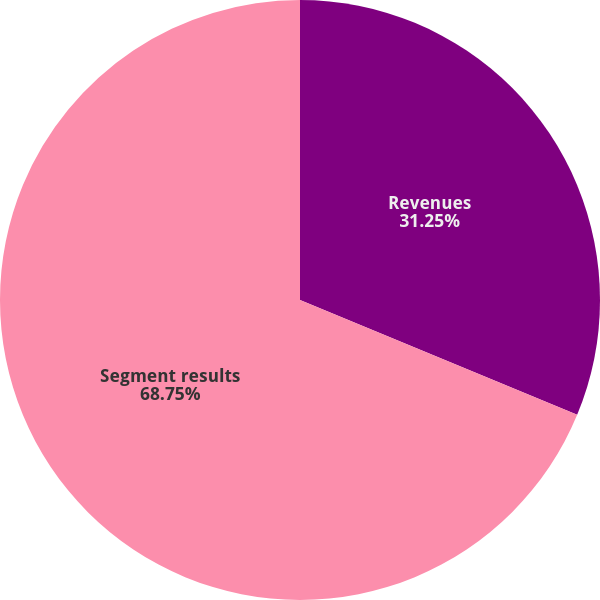<chart> <loc_0><loc_0><loc_500><loc_500><pie_chart><fcel>Revenues<fcel>Segment results<nl><fcel>31.25%<fcel>68.75%<nl></chart> 